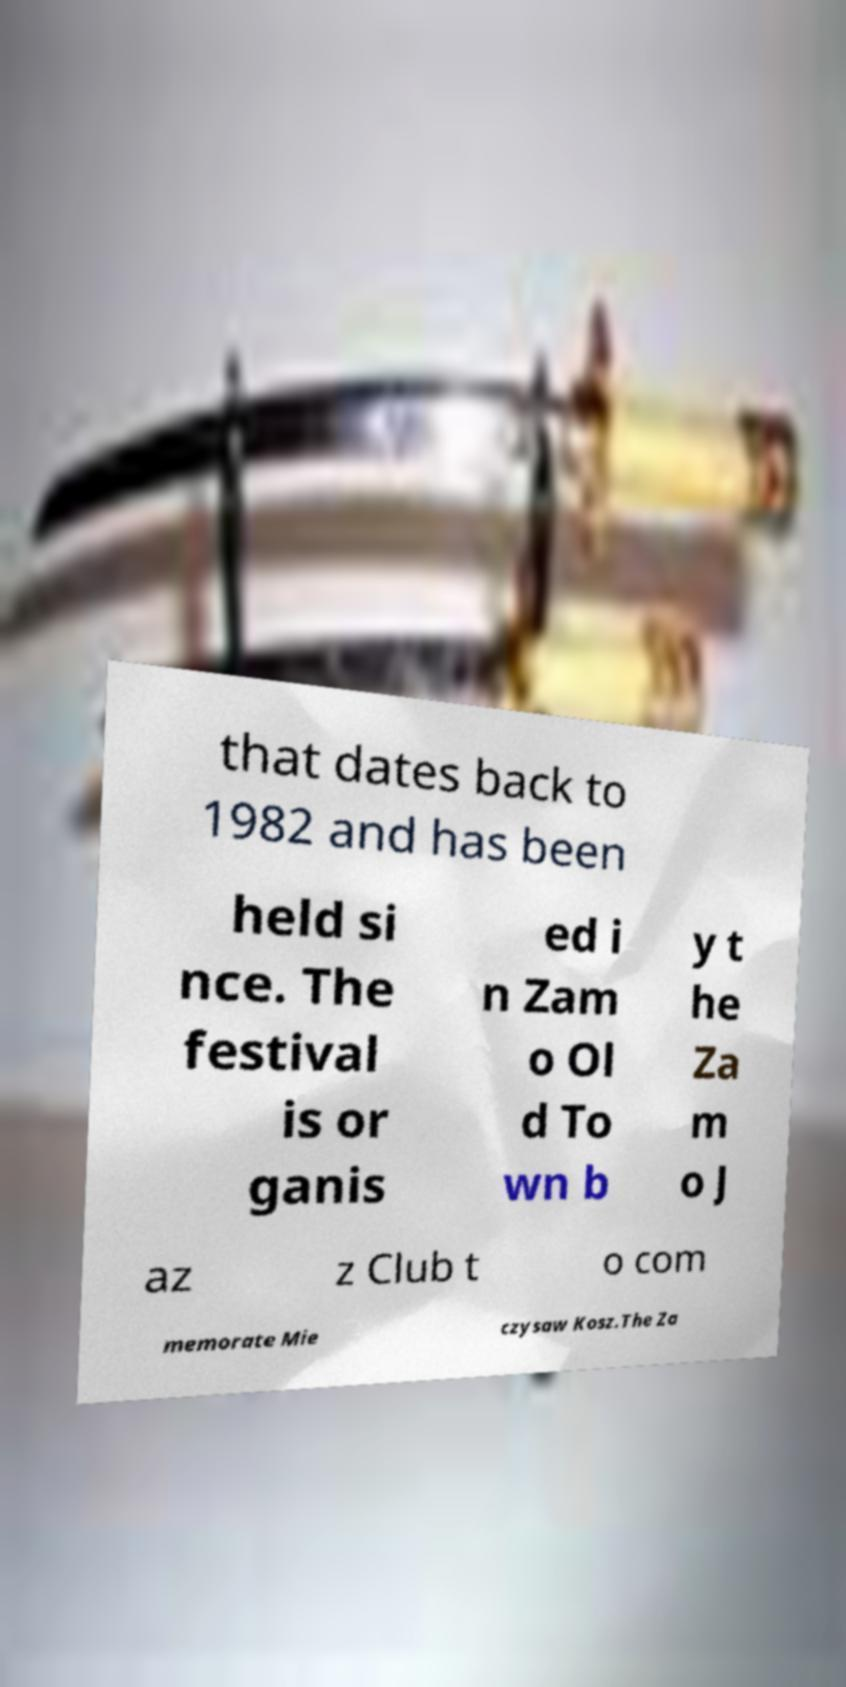Can you accurately transcribe the text from the provided image for me? that dates back to 1982 and has been held si nce. The festival is or ganis ed i n Zam o Ol d To wn b y t he Za m o J az z Club t o com memorate Mie czysaw Kosz.The Za 